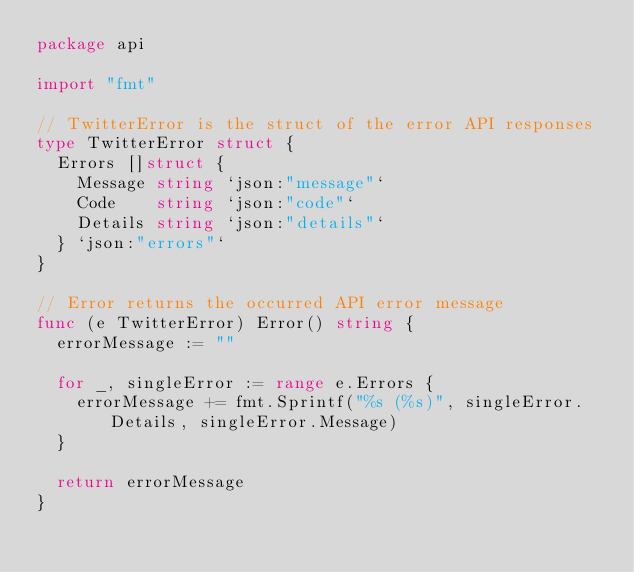Convert code to text. <code><loc_0><loc_0><loc_500><loc_500><_Go_>package api

import "fmt"

// TwitterError is the struct of the error API responses
type TwitterError struct {
	Errors []struct {
		Message string `json:"message"`
		Code    string `json:"code"`
		Details string `json:"details"`
	} `json:"errors"`
}

// Error returns the occurred API error message
func (e TwitterError) Error() string {
	errorMessage := ""

	for _, singleError := range e.Errors {
		errorMessage += fmt.Sprintf("%s (%s)", singleError.Details, singleError.Message)
	}

	return errorMessage
}
</code> 